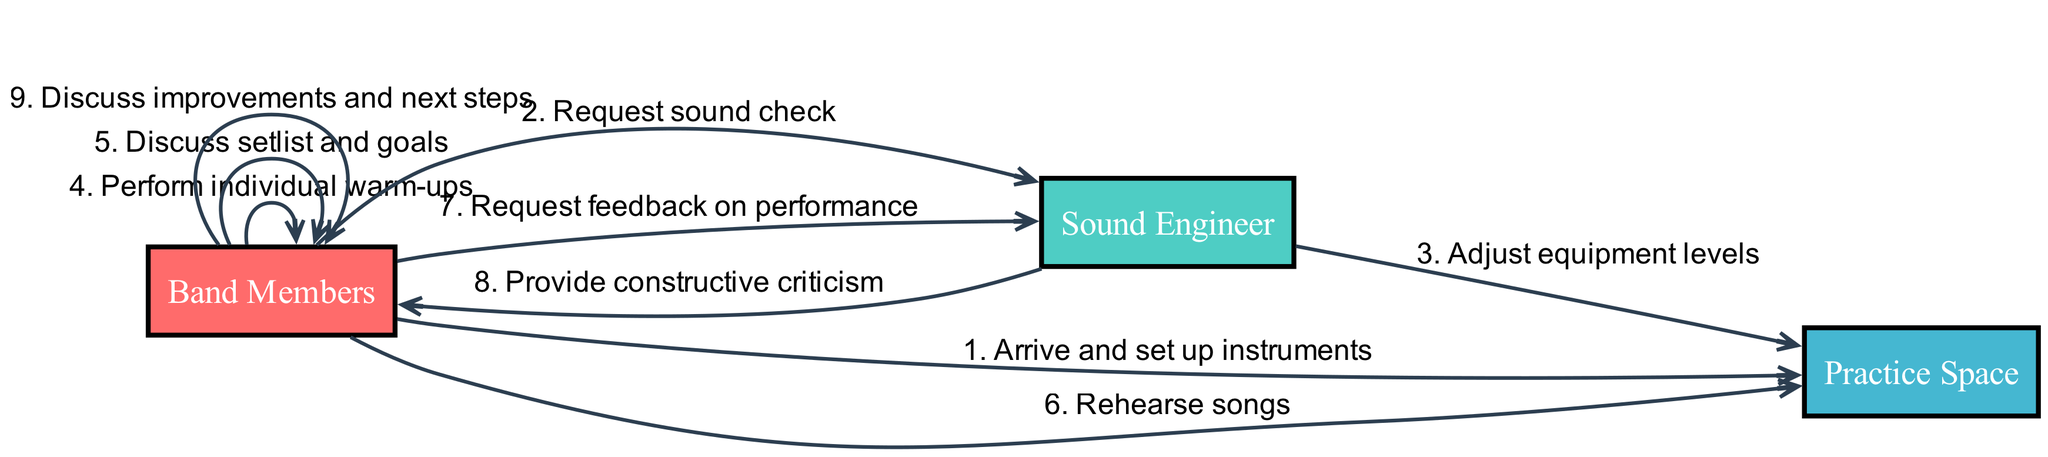What is the first action performed in the workflow? The diagram shows that the first action performed is "Arrive and set up instruments" from "Band Members" to "Practice Space." This can be identified as the first entry in the sequence list.
Answer: Arrive and set up instruments How many actors are involved in the diagram? The diagram lists three distinct actors: "Band Members," "Sound Engineer," and "Practice Space," which can be counted directly from the actors section.
Answer: 3 What action follows the request for a sound check? According to the sequence flow, the action that follows is "Adjust equipment levels," which is the subsequent action taken by the "Sound Engineer." This can be determined by the order of events listed.
Answer: Adjust equipment levels Which two actors interact during the discussion of improvements and next steps? The action "Discuss improvements and next steps" involves only the "Band Members" actor. Since it's a self-action, they are the only actors interacting in this instance.
Answer: Band Members What type of feedback is provided by the Sound Engineer after the rehearsal? The sequence specifies that the "Sound Engineer" provides "constructive criticism" to the "Band Members" after they request feedback on their performance. This is directly stated in the action sequence.
Answer: Constructive criticism How many actions are taken after the warm-up? After the "Perform individual warm-ups" action, there are three subsequent actions: "Discuss setlist and goals," "Rehearse songs," and "Request feedback on performance." Counting these provides the answer.
Answer: 3 What is the last action recorded in the workflow? The last action in the sequence is "Discuss improvements and next steps," which is the final entry in the actions list. This can be validated by looking at the last item in the sequence.
Answer: Discuss improvements and next steps Which actor is involved in adjusting equipment levels? The action "Adjust equipment levels" is conducted by the "Sound Engineer," according to the sequence that shows this direct interaction with the "Practice Space."
Answer: Sound Engineer What is the primary role of "Practice Space" in the workflow? The "Practice Space" primarily serves as the venue for actions such as setting up instruments, rehearsing songs, and adjustments by the sound engineer. It acts as the central space involved in actions, providing a location for the workflow.
Answer: Venue 